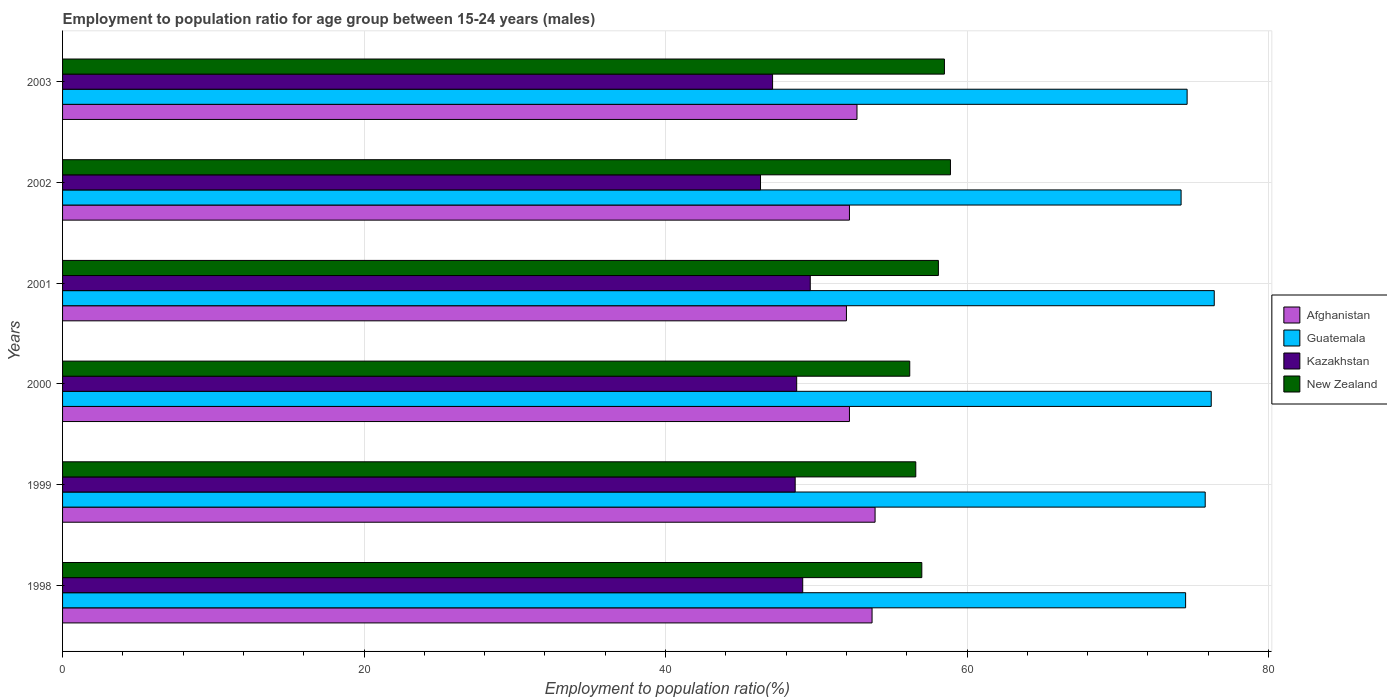Are the number of bars per tick equal to the number of legend labels?
Give a very brief answer. Yes. How many bars are there on the 3rd tick from the top?
Make the answer very short. 4. How many bars are there on the 4th tick from the bottom?
Provide a short and direct response. 4. In how many cases, is the number of bars for a given year not equal to the number of legend labels?
Offer a very short reply. 0. What is the employment to population ratio in Kazakhstan in 2001?
Your answer should be compact. 49.6. Across all years, what is the maximum employment to population ratio in Kazakhstan?
Give a very brief answer. 49.6. In which year was the employment to population ratio in Afghanistan maximum?
Make the answer very short. 1999. In which year was the employment to population ratio in Kazakhstan minimum?
Your response must be concise. 2002. What is the total employment to population ratio in Afghanistan in the graph?
Give a very brief answer. 316.7. What is the difference between the employment to population ratio in Afghanistan in 2001 and that in 2003?
Keep it short and to the point. -0.7. What is the difference between the employment to population ratio in Kazakhstan in 2000 and the employment to population ratio in New Zealand in 2002?
Make the answer very short. -10.2. What is the average employment to population ratio in Guatemala per year?
Give a very brief answer. 75.28. In the year 2002, what is the difference between the employment to population ratio in Kazakhstan and employment to population ratio in Guatemala?
Your answer should be very brief. -27.9. In how many years, is the employment to population ratio in Kazakhstan greater than 52 %?
Provide a succinct answer. 0. What is the ratio of the employment to population ratio in Guatemala in 1999 to that in 2001?
Ensure brevity in your answer.  0.99. Is the employment to population ratio in Kazakhstan in 1999 less than that in 2002?
Keep it short and to the point. No. Is the difference between the employment to population ratio in Kazakhstan in 1998 and 2001 greater than the difference between the employment to population ratio in Guatemala in 1998 and 2001?
Provide a short and direct response. Yes. What is the difference between the highest and the second highest employment to population ratio in Kazakhstan?
Give a very brief answer. 0.5. What is the difference between the highest and the lowest employment to population ratio in Guatemala?
Ensure brevity in your answer.  2.2. Is the sum of the employment to population ratio in New Zealand in 1999 and 2003 greater than the maximum employment to population ratio in Guatemala across all years?
Your answer should be compact. Yes. Is it the case that in every year, the sum of the employment to population ratio in Afghanistan and employment to population ratio in New Zealand is greater than the sum of employment to population ratio in Guatemala and employment to population ratio in Kazakhstan?
Provide a short and direct response. No. What does the 2nd bar from the top in 1998 represents?
Offer a very short reply. Kazakhstan. What does the 3rd bar from the bottom in 2003 represents?
Ensure brevity in your answer.  Kazakhstan. Is it the case that in every year, the sum of the employment to population ratio in Guatemala and employment to population ratio in Kazakhstan is greater than the employment to population ratio in New Zealand?
Offer a very short reply. Yes. Are all the bars in the graph horizontal?
Offer a terse response. Yes. What is the difference between two consecutive major ticks on the X-axis?
Your response must be concise. 20. Are the values on the major ticks of X-axis written in scientific E-notation?
Make the answer very short. No. How many legend labels are there?
Your answer should be very brief. 4. What is the title of the graph?
Give a very brief answer. Employment to population ratio for age group between 15-24 years (males). What is the Employment to population ratio(%) of Afghanistan in 1998?
Offer a very short reply. 53.7. What is the Employment to population ratio(%) in Guatemala in 1998?
Ensure brevity in your answer.  74.5. What is the Employment to population ratio(%) of Kazakhstan in 1998?
Your response must be concise. 49.1. What is the Employment to population ratio(%) in New Zealand in 1998?
Your response must be concise. 57. What is the Employment to population ratio(%) of Afghanistan in 1999?
Offer a very short reply. 53.9. What is the Employment to population ratio(%) in Guatemala in 1999?
Your answer should be compact. 75.8. What is the Employment to population ratio(%) in Kazakhstan in 1999?
Offer a very short reply. 48.6. What is the Employment to population ratio(%) of New Zealand in 1999?
Ensure brevity in your answer.  56.6. What is the Employment to population ratio(%) of Afghanistan in 2000?
Offer a very short reply. 52.2. What is the Employment to population ratio(%) of Guatemala in 2000?
Ensure brevity in your answer.  76.2. What is the Employment to population ratio(%) of Kazakhstan in 2000?
Keep it short and to the point. 48.7. What is the Employment to population ratio(%) in New Zealand in 2000?
Make the answer very short. 56.2. What is the Employment to population ratio(%) in Afghanistan in 2001?
Ensure brevity in your answer.  52. What is the Employment to population ratio(%) of Guatemala in 2001?
Offer a terse response. 76.4. What is the Employment to population ratio(%) of Kazakhstan in 2001?
Your answer should be very brief. 49.6. What is the Employment to population ratio(%) in New Zealand in 2001?
Offer a terse response. 58.1. What is the Employment to population ratio(%) of Afghanistan in 2002?
Give a very brief answer. 52.2. What is the Employment to population ratio(%) of Guatemala in 2002?
Offer a terse response. 74.2. What is the Employment to population ratio(%) in Kazakhstan in 2002?
Make the answer very short. 46.3. What is the Employment to population ratio(%) of New Zealand in 2002?
Offer a terse response. 58.9. What is the Employment to population ratio(%) in Afghanistan in 2003?
Offer a terse response. 52.7. What is the Employment to population ratio(%) in Guatemala in 2003?
Provide a short and direct response. 74.6. What is the Employment to population ratio(%) in Kazakhstan in 2003?
Your answer should be very brief. 47.1. What is the Employment to population ratio(%) in New Zealand in 2003?
Offer a terse response. 58.5. Across all years, what is the maximum Employment to population ratio(%) in Afghanistan?
Offer a very short reply. 53.9. Across all years, what is the maximum Employment to population ratio(%) in Guatemala?
Give a very brief answer. 76.4. Across all years, what is the maximum Employment to population ratio(%) in Kazakhstan?
Offer a very short reply. 49.6. Across all years, what is the maximum Employment to population ratio(%) in New Zealand?
Provide a short and direct response. 58.9. Across all years, what is the minimum Employment to population ratio(%) of Afghanistan?
Offer a terse response. 52. Across all years, what is the minimum Employment to population ratio(%) in Guatemala?
Your answer should be compact. 74.2. Across all years, what is the minimum Employment to population ratio(%) in Kazakhstan?
Keep it short and to the point. 46.3. Across all years, what is the minimum Employment to population ratio(%) of New Zealand?
Your answer should be compact. 56.2. What is the total Employment to population ratio(%) of Afghanistan in the graph?
Make the answer very short. 316.7. What is the total Employment to population ratio(%) in Guatemala in the graph?
Provide a short and direct response. 451.7. What is the total Employment to population ratio(%) in Kazakhstan in the graph?
Offer a very short reply. 289.4. What is the total Employment to population ratio(%) in New Zealand in the graph?
Provide a short and direct response. 345.3. What is the difference between the Employment to population ratio(%) of Afghanistan in 1998 and that in 1999?
Your response must be concise. -0.2. What is the difference between the Employment to population ratio(%) in Guatemala in 1998 and that in 1999?
Ensure brevity in your answer.  -1.3. What is the difference between the Employment to population ratio(%) in Kazakhstan in 1998 and that in 1999?
Give a very brief answer. 0.5. What is the difference between the Employment to population ratio(%) of Kazakhstan in 1998 and that in 2000?
Keep it short and to the point. 0.4. What is the difference between the Employment to population ratio(%) of Afghanistan in 1998 and that in 2002?
Your answer should be compact. 1.5. What is the difference between the Employment to population ratio(%) in Kazakhstan in 1998 and that in 2003?
Offer a terse response. 2. What is the difference between the Employment to population ratio(%) of New Zealand in 1998 and that in 2003?
Give a very brief answer. -1.5. What is the difference between the Employment to population ratio(%) in Afghanistan in 1999 and that in 2000?
Make the answer very short. 1.7. What is the difference between the Employment to population ratio(%) in Guatemala in 1999 and that in 2000?
Offer a terse response. -0.4. What is the difference between the Employment to population ratio(%) of Kazakhstan in 1999 and that in 2000?
Offer a very short reply. -0.1. What is the difference between the Employment to population ratio(%) in New Zealand in 1999 and that in 2000?
Make the answer very short. 0.4. What is the difference between the Employment to population ratio(%) of Afghanistan in 1999 and that in 2001?
Give a very brief answer. 1.9. What is the difference between the Employment to population ratio(%) of Guatemala in 1999 and that in 2001?
Make the answer very short. -0.6. What is the difference between the Employment to population ratio(%) of New Zealand in 1999 and that in 2001?
Ensure brevity in your answer.  -1.5. What is the difference between the Employment to population ratio(%) in Afghanistan in 1999 and that in 2002?
Your response must be concise. 1.7. What is the difference between the Employment to population ratio(%) in Guatemala in 1999 and that in 2002?
Provide a succinct answer. 1.6. What is the difference between the Employment to population ratio(%) in Afghanistan in 1999 and that in 2003?
Provide a short and direct response. 1.2. What is the difference between the Employment to population ratio(%) of New Zealand in 1999 and that in 2003?
Your answer should be compact. -1.9. What is the difference between the Employment to population ratio(%) of Afghanistan in 2000 and that in 2001?
Make the answer very short. 0.2. What is the difference between the Employment to population ratio(%) of Guatemala in 2000 and that in 2002?
Offer a terse response. 2. What is the difference between the Employment to population ratio(%) in New Zealand in 2000 and that in 2002?
Provide a succinct answer. -2.7. What is the difference between the Employment to population ratio(%) of Kazakhstan in 2000 and that in 2003?
Your response must be concise. 1.6. What is the difference between the Employment to population ratio(%) in New Zealand in 2000 and that in 2003?
Your answer should be compact. -2.3. What is the difference between the Employment to population ratio(%) of New Zealand in 2001 and that in 2002?
Provide a short and direct response. -0.8. What is the difference between the Employment to population ratio(%) in New Zealand in 2001 and that in 2003?
Offer a very short reply. -0.4. What is the difference between the Employment to population ratio(%) in Kazakhstan in 2002 and that in 2003?
Your response must be concise. -0.8. What is the difference between the Employment to population ratio(%) of Afghanistan in 1998 and the Employment to population ratio(%) of Guatemala in 1999?
Offer a terse response. -22.1. What is the difference between the Employment to population ratio(%) of Afghanistan in 1998 and the Employment to population ratio(%) of Kazakhstan in 1999?
Keep it short and to the point. 5.1. What is the difference between the Employment to population ratio(%) in Afghanistan in 1998 and the Employment to population ratio(%) in New Zealand in 1999?
Your answer should be very brief. -2.9. What is the difference between the Employment to population ratio(%) in Guatemala in 1998 and the Employment to population ratio(%) in Kazakhstan in 1999?
Your answer should be very brief. 25.9. What is the difference between the Employment to population ratio(%) in Guatemala in 1998 and the Employment to population ratio(%) in New Zealand in 1999?
Offer a terse response. 17.9. What is the difference between the Employment to population ratio(%) in Kazakhstan in 1998 and the Employment to population ratio(%) in New Zealand in 1999?
Ensure brevity in your answer.  -7.5. What is the difference between the Employment to population ratio(%) of Afghanistan in 1998 and the Employment to population ratio(%) of Guatemala in 2000?
Offer a very short reply. -22.5. What is the difference between the Employment to population ratio(%) in Afghanistan in 1998 and the Employment to population ratio(%) in New Zealand in 2000?
Keep it short and to the point. -2.5. What is the difference between the Employment to population ratio(%) in Guatemala in 1998 and the Employment to population ratio(%) in Kazakhstan in 2000?
Your response must be concise. 25.8. What is the difference between the Employment to population ratio(%) in Kazakhstan in 1998 and the Employment to population ratio(%) in New Zealand in 2000?
Keep it short and to the point. -7.1. What is the difference between the Employment to population ratio(%) of Afghanistan in 1998 and the Employment to population ratio(%) of Guatemala in 2001?
Keep it short and to the point. -22.7. What is the difference between the Employment to population ratio(%) of Guatemala in 1998 and the Employment to population ratio(%) of Kazakhstan in 2001?
Your response must be concise. 24.9. What is the difference between the Employment to population ratio(%) in Guatemala in 1998 and the Employment to population ratio(%) in New Zealand in 2001?
Keep it short and to the point. 16.4. What is the difference between the Employment to population ratio(%) of Kazakhstan in 1998 and the Employment to population ratio(%) of New Zealand in 2001?
Ensure brevity in your answer.  -9. What is the difference between the Employment to population ratio(%) in Afghanistan in 1998 and the Employment to population ratio(%) in Guatemala in 2002?
Your response must be concise. -20.5. What is the difference between the Employment to population ratio(%) of Afghanistan in 1998 and the Employment to population ratio(%) of New Zealand in 2002?
Offer a terse response. -5.2. What is the difference between the Employment to population ratio(%) in Guatemala in 1998 and the Employment to population ratio(%) in Kazakhstan in 2002?
Make the answer very short. 28.2. What is the difference between the Employment to population ratio(%) of Kazakhstan in 1998 and the Employment to population ratio(%) of New Zealand in 2002?
Ensure brevity in your answer.  -9.8. What is the difference between the Employment to population ratio(%) in Afghanistan in 1998 and the Employment to population ratio(%) in Guatemala in 2003?
Provide a succinct answer. -20.9. What is the difference between the Employment to population ratio(%) of Afghanistan in 1998 and the Employment to population ratio(%) of Kazakhstan in 2003?
Offer a very short reply. 6.6. What is the difference between the Employment to population ratio(%) in Guatemala in 1998 and the Employment to population ratio(%) in Kazakhstan in 2003?
Provide a succinct answer. 27.4. What is the difference between the Employment to population ratio(%) of Guatemala in 1998 and the Employment to population ratio(%) of New Zealand in 2003?
Give a very brief answer. 16. What is the difference between the Employment to population ratio(%) of Kazakhstan in 1998 and the Employment to population ratio(%) of New Zealand in 2003?
Your answer should be very brief. -9.4. What is the difference between the Employment to population ratio(%) of Afghanistan in 1999 and the Employment to population ratio(%) of Guatemala in 2000?
Provide a succinct answer. -22.3. What is the difference between the Employment to population ratio(%) of Afghanistan in 1999 and the Employment to population ratio(%) of Kazakhstan in 2000?
Provide a short and direct response. 5.2. What is the difference between the Employment to population ratio(%) of Guatemala in 1999 and the Employment to population ratio(%) of Kazakhstan in 2000?
Make the answer very short. 27.1. What is the difference between the Employment to population ratio(%) of Guatemala in 1999 and the Employment to population ratio(%) of New Zealand in 2000?
Provide a succinct answer. 19.6. What is the difference between the Employment to population ratio(%) in Kazakhstan in 1999 and the Employment to population ratio(%) in New Zealand in 2000?
Your answer should be very brief. -7.6. What is the difference between the Employment to population ratio(%) in Afghanistan in 1999 and the Employment to population ratio(%) in Guatemala in 2001?
Your answer should be very brief. -22.5. What is the difference between the Employment to population ratio(%) of Afghanistan in 1999 and the Employment to population ratio(%) of Kazakhstan in 2001?
Keep it short and to the point. 4.3. What is the difference between the Employment to population ratio(%) of Afghanistan in 1999 and the Employment to population ratio(%) of New Zealand in 2001?
Your answer should be compact. -4.2. What is the difference between the Employment to population ratio(%) of Guatemala in 1999 and the Employment to population ratio(%) of Kazakhstan in 2001?
Provide a short and direct response. 26.2. What is the difference between the Employment to population ratio(%) of Guatemala in 1999 and the Employment to population ratio(%) of New Zealand in 2001?
Ensure brevity in your answer.  17.7. What is the difference between the Employment to population ratio(%) of Kazakhstan in 1999 and the Employment to population ratio(%) of New Zealand in 2001?
Make the answer very short. -9.5. What is the difference between the Employment to population ratio(%) of Afghanistan in 1999 and the Employment to population ratio(%) of Guatemala in 2002?
Make the answer very short. -20.3. What is the difference between the Employment to population ratio(%) of Afghanistan in 1999 and the Employment to population ratio(%) of Kazakhstan in 2002?
Offer a very short reply. 7.6. What is the difference between the Employment to population ratio(%) of Afghanistan in 1999 and the Employment to population ratio(%) of New Zealand in 2002?
Provide a short and direct response. -5. What is the difference between the Employment to population ratio(%) of Guatemala in 1999 and the Employment to population ratio(%) of Kazakhstan in 2002?
Offer a terse response. 29.5. What is the difference between the Employment to population ratio(%) of Afghanistan in 1999 and the Employment to population ratio(%) of Guatemala in 2003?
Give a very brief answer. -20.7. What is the difference between the Employment to population ratio(%) in Afghanistan in 1999 and the Employment to population ratio(%) in Kazakhstan in 2003?
Ensure brevity in your answer.  6.8. What is the difference between the Employment to population ratio(%) in Guatemala in 1999 and the Employment to population ratio(%) in Kazakhstan in 2003?
Your response must be concise. 28.7. What is the difference between the Employment to population ratio(%) of Guatemala in 1999 and the Employment to population ratio(%) of New Zealand in 2003?
Keep it short and to the point. 17.3. What is the difference between the Employment to population ratio(%) in Kazakhstan in 1999 and the Employment to population ratio(%) in New Zealand in 2003?
Your answer should be compact. -9.9. What is the difference between the Employment to population ratio(%) in Afghanistan in 2000 and the Employment to population ratio(%) in Guatemala in 2001?
Give a very brief answer. -24.2. What is the difference between the Employment to population ratio(%) of Afghanistan in 2000 and the Employment to population ratio(%) of Kazakhstan in 2001?
Offer a very short reply. 2.6. What is the difference between the Employment to population ratio(%) in Guatemala in 2000 and the Employment to population ratio(%) in Kazakhstan in 2001?
Your response must be concise. 26.6. What is the difference between the Employment to population ratio(%) in Afghanistan in 2000 and the Employment to population ratio(%) in New Zealand in 2002?
Keep it short and to the point. -6.7. What is the difference between the Employment to population ratio(%) of Guatemala in 2000 and the Employment to population ratio(%) of Kazakhstan in 2002?
Keep it short and to the point. 29.9. What is the difference between the Employment to population ratio(%) in Kazakhstan in 2000 and the Employment to population ratio(%) in New Zealand in 2002?
Your answer should be very brief. -10.2. What is the difference between the Employment to population ratio(%) of Afghanistan in 2000 and the Employment to population ratio(%) of Guatemala in 2003?
Give a very brief answer. -22.4. What is the difference between the Employment to population ratio(%) in Afghanistan in 2000 and the Employment to population ratio(%) in Kazakhstan in 2003?
Provide a short and direct response. 5.1. What is the difference between the Employment to population ratio(%) of Guatemala in 2000 and the Employment to population ratio(%) of Kazakhstan in 2003?
Your answer should be very brief. 29.1. What is the difference between the Employment to population ratio(%) in Kazakhstan in 2000 and the Employment to population ratio(%) in New Zealand in 2003?
Provide a short and direct response. -9.8. What is the difference between the Employment to population ratio(%) of Afghanistan in 2001 and the Employment to population ratio(%) of Guatemala in 2002?
Your answer should be compact. -22.2. What is the difference between the Employment to population ratio(%) of Guatemala in 2001 and the Employment to population ratio(%) of Kazakhstan in 2002?
Your response must be concise. 30.1. What is the difference between the Employment to population ratio(%) of Afghanistan in 2001 and the Employment to population ratio(%) of Guatemala in 2003?
Provide a short and direct response. -22.6. What is the difference between the Employment to population ratio(%) in Afghanistan in 2001 and the Employment to population ratio(%) in New Zealand in 2003?
Keep it short and to the point. -6.5. What is the difference between the Employment to population ratio(%) in Guatemala in 2001 and the Employment to population ratio(%) in Kazakhstan in 2003?
Offer a very short reply. 29.3. What is the difference between the Employment to population ratio(%) in Afghanistan in 2002 and the Employment to population ratio(%) in Guatemala in 2003?
Your answer should be compact. -22.4. What is the difference between the Employment to population ratio(%) in Afghanistan in 2002 and the Employment to population ratio(%) in Kazakhstan in 2003?
Give a very brief answer. 5.1. What is the difference between the Employment to population ratio(%) in Guatemala in 2002 and the Employment to population ratio(%) in Kazakhstan in 2003?
Offer a terse response. 27.1. What is the average Employment to population ratio(%) of Afghanistan per year?
Keep it short and to the point. 52.78. What is the average Employment to population ratio(%) in Guatemala per year?
Provide a succinct answer. 75.28. What is the average Employment to population ratio(%) of Kazakhstan per year?
Your response must be concise. 48.23. What is the average Employment to population ratio(%) in New Zealand per year?
Provide a succinct answer. 57.55. In the year 1998, what is the difference between the Employment to population ratio(%) of Afghanistan and Employment to population ratio(%) of Guatemala?
Your answer should be very brief. -20.8. In the year 1998, what is the difference between the Employment to population ratio(%) in Afghanistan and Employment to population ratio(%) in Kazakhstan?
Provide a short and direct response. 4.6. In the year 1998, what is the difference between the Employment to population ratio(%) of Afghanistan and Employment to population ratio(%) of New Zealand?
Offer a terse response. -3.3. In the year 1998, what is the difference between the Employment to population ratio(%) of Guatemala and Employment to population ratio(%) of Kazakhstan?
Ensure brevity in your answer.  25.4. In the year 1998, what is the difference between the Employment to population ratio(%) of Guatemala and Employment to population ratio(%) of New Zealand?
Make the answer very short. 17.5. In the year 1998, what is the difference between the Employment to population ratio(%) of Kazakhstan and Employment to population ratio(%) of New Zealand?
Ensure brevity in your answer.  -7.9. In the year 1999, what is the difference between the Employment to population ratio(%) in Afghanistan and Employment to population ratio(%) in Guatemala?
Offer a terse response. -21.9. In the year 1999, what is the difference between the Employment to population ratio(%) of Afghanistan and Employment to population ratio(%) of New Zealand?
Ensure brevity in your answer.  -2.7. In the year 1999, what is the difference between the Employment to population ratio(%) in Guatemala and Employment to population ratio(%) in Kazakhstan?
Offer a very short reply. 27.2. In the year 2000, what is the difference between the Employment to population ratio(%) of Afghanistan and Employment to population ratio(%) of Guatemala?
Ensure brevity in your answer.  -24. In the year 2000, what is the difference between the Employment to population ratio(%) in Guatemala and Employment to population ratio(%) in New Zealand?
Offer a very short reply. 20. In the year 2001, what is the difference between the Employment to population ratio(%) in Afghanistan and Employment to population ratio(%) in Guatemala?
Keep it short and to the point. -24.4. In the year 2001, what is the difference between the Employment to population ratio(%) of Afghanistan and Employment to population ratio(%) of New Zealand?
Offer a terse response. -6.1. In the year 2001, what is the difference between the Employment to population ratio(%) of Guatemala and Employment to population ratio(%) of Kazakhstan?
Offer a terse response. 26.8. In the year 2002, what is the difference between the Employment to population ratio(%) of Afghanistan and Employment to population ratio(%) of Guatemala?
Provide a short and direct response. -22. In the year 2002, what is the difference between the Employment to population ratio(%) in Afghanistan and Employment to population ratio(%) in Kazakhstan?
Your response must be concise. 5.9. In the year 2002, what is the difference between the Employment to population ratio(%) of Afghanistan and Employment to population ratio(%) of New Zealand?
Give a very brief answer. -6.7. In the year 2002, what is the difference between the Employment to population ratio(%) in Guatemala and Employment to population ratio(%) in Kazakhstan?
Your response must be concise. 27.9. In the year 2002, what is the difference between the Employment to population ratio(%) in Guatemala and Employment to population ratio(%) in New Zealand?
Offer a terse response. 15.3. In the year 2003, what is the difference between the Employment to population ratio(%) of Afghanistan and Employment to population ratio(%) of Guatemala?
Your answer should be compact. -21.9. In the year 2003, what is the difference between the Employment to population ratio(%) of Afghanistan and Employment to population ratio(%) of Kazakhstan?
Provide a succinct answer. 5.6. In the year 2003, what is the difference between the Employment to population ratio(%) of Afghanistan and Employment to population ratio(%) of New Zealand?
Keep it short and to the point. -5.8. What is the ratio of the Employment to population ratio(%) in Guatemala in 1998 to that in 1999?
Your answer should be very brief. 0.98. What is the ratio of the Employment to population ratio(%) in Kazakhstan in 1998 to that in 1999?
Make the answer very short. 1.01. What is the ratio of the Employment to population ratio(%) of New Zealand in 1998 to that in 1999?
Offer a very short reply. 1.01. What is the ratio of the Employment to population ratio(%) of Afghanistan in 1998 to that in 2000?
Your response must be concise. 1.03. What is the ratio of the Employment to population ratio(%) of Guatemala in 1998 to that in 2000?
Your answer should be compact. 0.98. What is the ratio of the Employment to population ratio(%) in Kazakhstan in 1998 to that in 2000?
Make the answer very short. 1.01. What is the ratio of the Employment to population ratio(%) of New Zealand in 1998 to that in 2000?
Provide a short and direct response. 1.01. What is the ratio of the Employment to population ratio(%) in Afghanistan in 1998 to that in 2001?
Make the answer very short. 1.03. What is the ratio of the Employment to population ratio(%) in Guatemala in 1998 to that in 2001?
Give a very brief answer. 0.98. What is the ratio of the Employment to population ratio(%) of Kazakhstan in 1998 to that in 2001?
Your response must be concise. 0.99. What is the ratio of the Employment to population ratio(%) in New Zealand in 1998 to that in 2001?
Ensure brevity in your answer.  0.98. What is the ratio of the Employment to population ratio(%) of Afghanistan in 1998 to that in 2002?
Make the answer very short. 1.03. What is the ratio of the Employment to population ratio(%) in Kazakhstan in 1998 to that in 2002?
Offer a terse response. 1.06. What is the ratio of the Employment to population ratio(%) of New Zealand in 1998 to that in 2002?
Give a very brief answer. 0.97. What is the ratio of the Employment to population ratio(%) in Afghanistan in 1998 to that in 2003?
Your response must be concise. 1.02. What is the ratio of the Employment to population ratio(%) of Kazakhstan in 1998 to that in 2003?
Your answer should be very brief. 1.04. What is the ratio of the Employment to population ratio(%) of New Zealand in 1998 to that in 2003?
Make the answer very short. 0.97. What is the ratio of the Employment to population ratio(%) of Afghanistan in 1999 to that in 2000?
Your answer should be very brief. 1.03. What is the ratio of the Employment to population ratio(%) in Guatemala in 1999 to that in 2000?
Your answer should be very brief. 0.99. What is the ratio of the Employment to population ratio(%) of New Zealand in 1999 to that in 2000?
Offer a very short reply. 1.01. What is the ratio of the Employment to population ratio(%) of Afghanistan in 1999 to that in 2001?
Provide a succinct answer. 1.04. What is the ratio of the Employment to population ratio(%) of Kazakhstan in 1999 to that in 2001?
Provide a succinct answer. 0.98. What is the ratio of the Employment to population ratio(%) of New Zealand in 1999 to that in 2001?
Offer a very short reply. 0.97. What is the ratio of the Employment to population ratio(%) in Afghanistan in 1999 to that in 2002?
Provide a succinct answer. 1.03. What is the ratio of the Employment to population ratio(%) in Guatemala in 1999 to that in 2002?
Your response must be concise. 1.02. What is the ratio of the Employment to population ratio(%) in Kazakhstan in 1999 to that in 2002?
Your answer should be compact. 1.05. What is the ratio of the Employment to population ratio(%) of Afghanistan in 1999 to that in 2003?
Offer a terse response. 1.02. What is the ratio of the Employment to population ratio(%) in Guatemala in 1999 to that in 2003?
Provide a succinct answer. 1.02. What is the ratio of the Employment to population ratio(%) in Kazakhstan in 1999 to that in 2003?
Keep it short and to the point. 1.03. What is the ratio of the Employment to population ratio(%) in New Zealand in 1999 to that in 2003?
Offer a terse response. 0.97. What is the ratio of the Employment to population ratio(%) of Afghanistan in 2000 to that in 2001?
Offer a very short reply. 1. What is the ratio of the Employment to population ratio(%) of Kazakhstan in 2000 to that in 2001?
Offer a terse response. 0.98. What is the ratio of the Employment to population ratio(%) in New Zealand in 2000 to that in 2001?
Offer a very short reply. 0.97. What is the ratio of the Employment to population ratio(%) of Guatemala in 2000 to that in 2002?
Keep it short and to the point. 1.03. What is the ratio of the Employment to population ratio(%) of Kazakhstan in 2000 to that in 2002?
Your answer should be very brief. 1.05. What is the ratio of the Employment to population ratio(%) in New Zealand in 2000 to that in 2002?
Keep it short and to the point. 0.95. What is the ratio of the Employment to population ratio(%) in Afghanistan in 2000 to that in 2003?
Offer a terse response. 0.99. What is the ratio of the Employment to population ratio(%) of Guatemala in 2000 to that in 2003?
Keep it short and to the point. 1.02. What is the ratio of the Employment to population ratio(%) of Kazakhstan in 2000 to that in 2003?
Provide a succinct answer. 1.03. What is the ratio of the Employment to population ratio(%) of New Zealand in 2000 to that in 2003?
Your answer should be very brief. 0.96. What is the ratio of the Employment to population ratio(%) of Afghanistan in 2001 to that in 2002?
Your response must be concise. 1. What is the ratio of the Employment to population ratio(%) in Guatemala in 2001 to that in 2002?
Offer a very short reply. 1.03. What is the ratio of the Employment to population ratio(%) in Kazakhstan in 2001 to that in 2002?
Keep it short and to the point. 1.07. What is the ratio of the Employment to population ratio(%) of New Zealand in 2001 to that in 2002?
Give a very brief answer. 0.99. What is the ratio of the Employment to population ratio(%) in Afghanistan in 2001 to that in 2003?
Give a very brief answer. 0.99. What is the ratio of the Employment to population ratio(%) of Guatemala in 2001 to that in 2003?
Provide a short and direct response. 1.02. What is the ratio of the Employment to population ratio(%) of Kazakhstan in 2001 to that in 2003?
Your answer should be very brief. 1.05. What is the ratio of the Employment to population ratio(%) of New Zealand in 2001 to that in 2003?
Ensure brevity in your answer.  0.99. What is the ratio of the Employment to population ratio(%) in Kazakhstan in 2002 to that in 2003?
Offer a very short reply. 0.98. What is the ratio of the Employment to population ratio(%) in New Zealand in 2002 to that in 2003?
Offer a very short reply. 1.01. What is the difference between the highest and the second highest Employment to population ratio(%) of Afghanistan?
Give a very brief answer. 0.2. What is the difference between the highest and the second highest Employment to population ratio(%) in Guatemala?
Give a very brief answer. 0.2. What is the difference between the highest and the lowest Employment to population ratio(%) of Guatemala?
Ensure brevity in your answer.  2.2. 